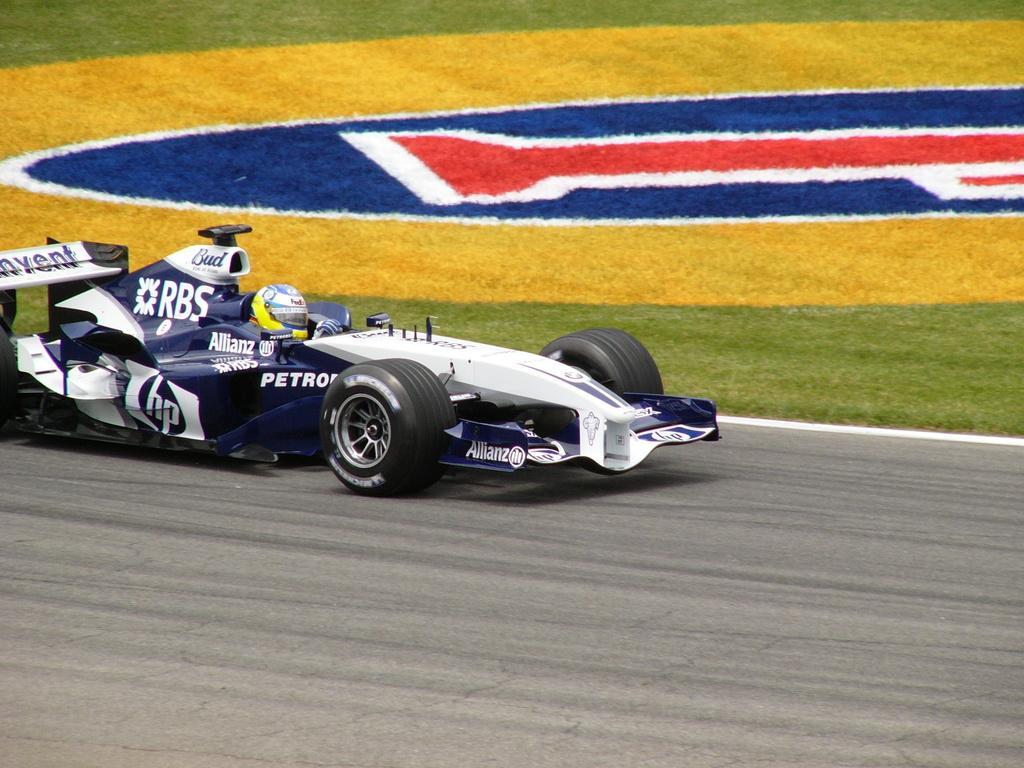What is the main subject of the image? There is a vehicle on the road in the image. What can be seen in the background of the image? There is grass and a design on the ground visible in the background of the image. Where is the pig located in the image? There is no pig present in the image. What type of tool is being used to clean the sidewalk in the image? There is no sidewalk or rake present in the image. 